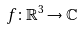<formula> <loc_0><loc_0><loc_500><loc_500>f \colon \mathbb { R } ^ { 3 } \to \mathbb { C }</formula> 